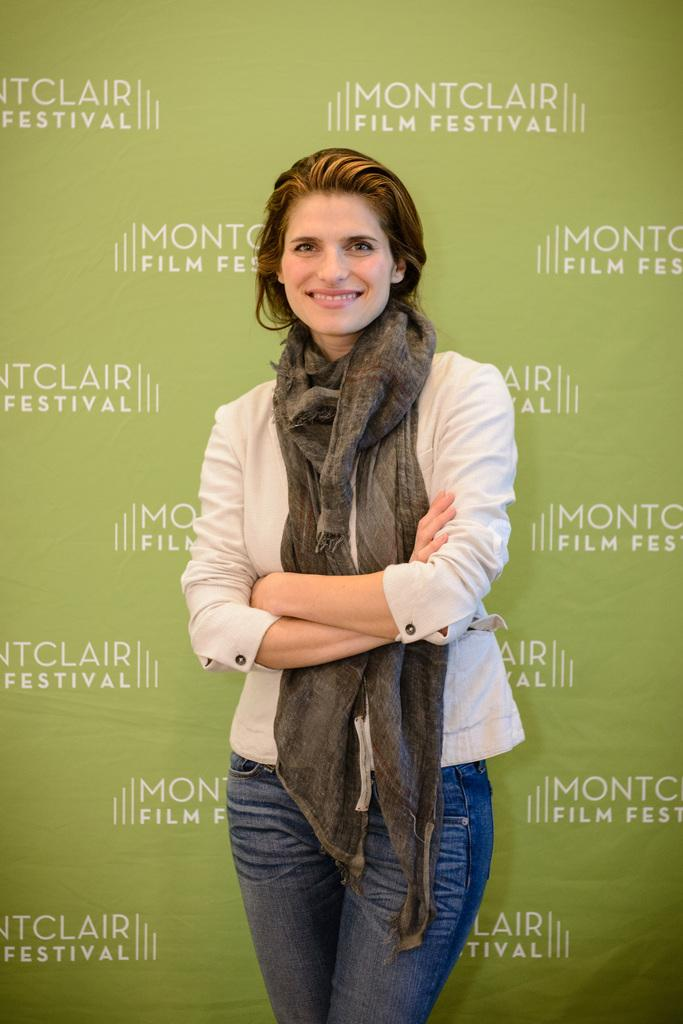Who or what is present in the image? There is a person in the image. What is the person wearing? The person is wearing clothes. What is behind the person in the image? The person is standing in front of a flex board. What type of tax is being discussed on the flex board in the image? There is no indication of a tax being discussed on the flex board in the image. 